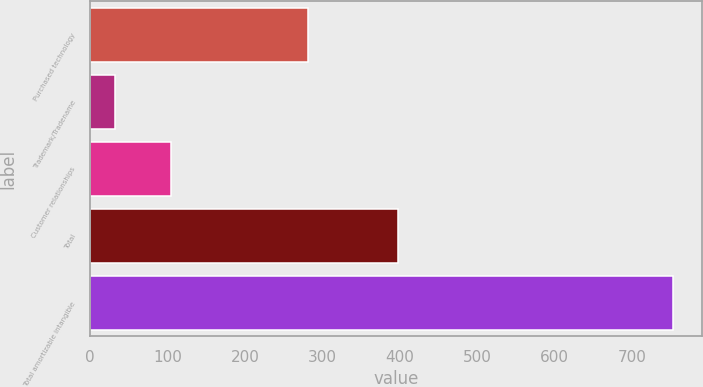<chart> <loc_0><loc_0><loc_500><loc_500><bar_chart><fcel>Purchased technology<fcel>Trademark/Tradename<fcel>Customer relationships<fcel>Total<fcel>Total amortizable intangible<nl><fcel>281<fcel>32<fcel>104.1<fcel>398<fcel>753<nl></chart> 